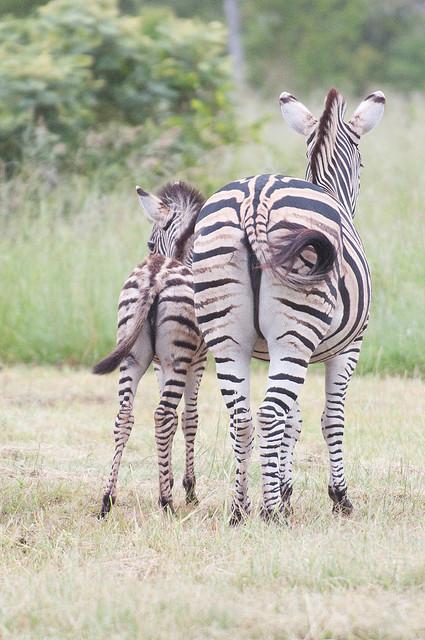Are these zebras mother and child?
Quick response, please. Yes. Is the grass tall?
Be succinct. Yes. How many zebras are there?
Short answer required. 2. Are the animals running?
Short answer required. No. Is this a zoo?
Quick response, please. No. 